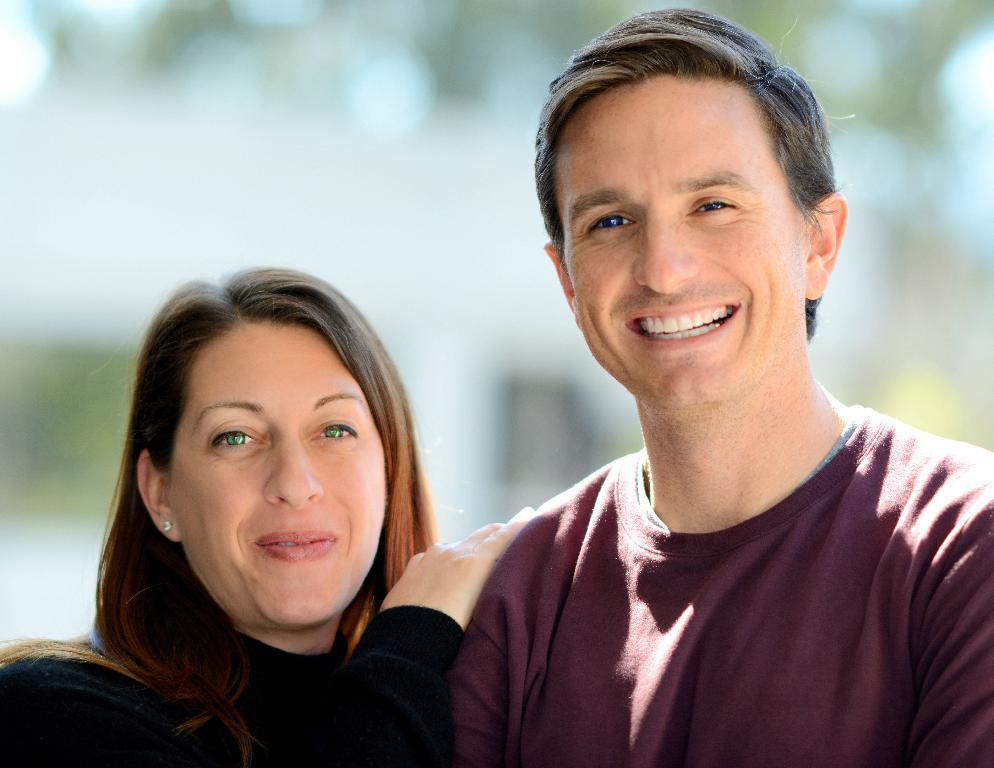How many people are in the image? There are two people in the image. What expressions do the people have? Both people are smiling. What colors are the dresses worn by the people? One person is wearing a black dress, and the other person is wearing a brown dress. Can you describe the background of the image? The background of the image is blurred. How many feet can be seen in the image? There is no information about feet in the image, as it focuses on the people's faces and dresses. --- Facts: 1. There is a car in the image. 2. The car is red. 3. The car has four wheels. 4. The car has a sunroof. 5. There are trees in the background of the image. Absurd Topics: parrot, ocean, dance Conversation: What is the main subject of the image? The main subject of the image is a car. What color is the car? The car is red. How many wheels does the car have? The car has four wheels. What feature does the car have on its roof? The car has a sunroof. What can be seen in the background of the image? There are trees in the background of the image. Reasoning: Let's think step by step in order to produce the conversation. We start by identifying the main subject of the image, which is the car. Then, we describe the color and features of the car, including the number of wheels and the presence of a sunroof. Finally, we mention the background of the image, which is the trees. Each question is designed to elicit a specific detail about the image that is known from the provided facts. Absurd Question/Answer: Can you tell me how many parrots are sitting on the car's hood in the image? There are no parrots present in the image; it only features a red car with four wheels and a sunroof. 